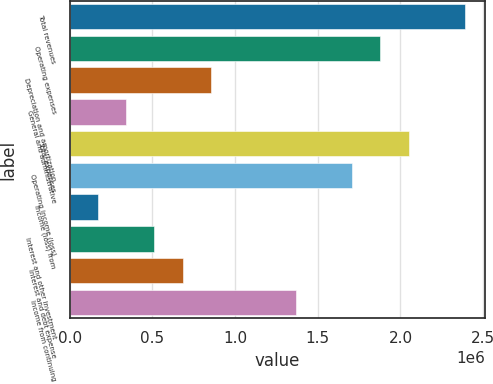Convert chart. <chart><loc_0><loc_0><loc_500><loc_500><bar_chart><fcel>Total revenues<fcel>Operating expenses<fcel>Depreciation and amortization<fcel>General and administrative<fcel>Total expenses<fcel>Operating income (loss)<fcel>Income (loss) from<fcel>Interest and other investment<fcel>Interest and debt expense<fcel>Income from continuing<nl><fcel>2.39013e+06<fcel>1.87798e+06<fcel>853681<fcel>341532<fcel>2.04869e+06<fcel>1.70726e+06<fcel>170816<fcel>512249<fcel>682965<fcel>1.36583e+06<nl></chart> 